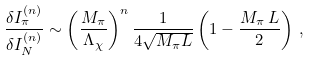<formula> <loc_0><loc_0><loc_500><loc_500>\frac { \delta I _ { \pi } ^ { ( n ) } } { \delta I _ { N } ^ { ( n ) } } \sim \left ( \frac { M _ { \pi } } { \Lambda _ { \chi } } \right ) ^ { n } \frac { 1 } { 4 \sqrt { M _ { \pi } L } } \left ( 1 - \frac { M _ { \pi } \, L } { 2 } \right ) \, ,</formula> 